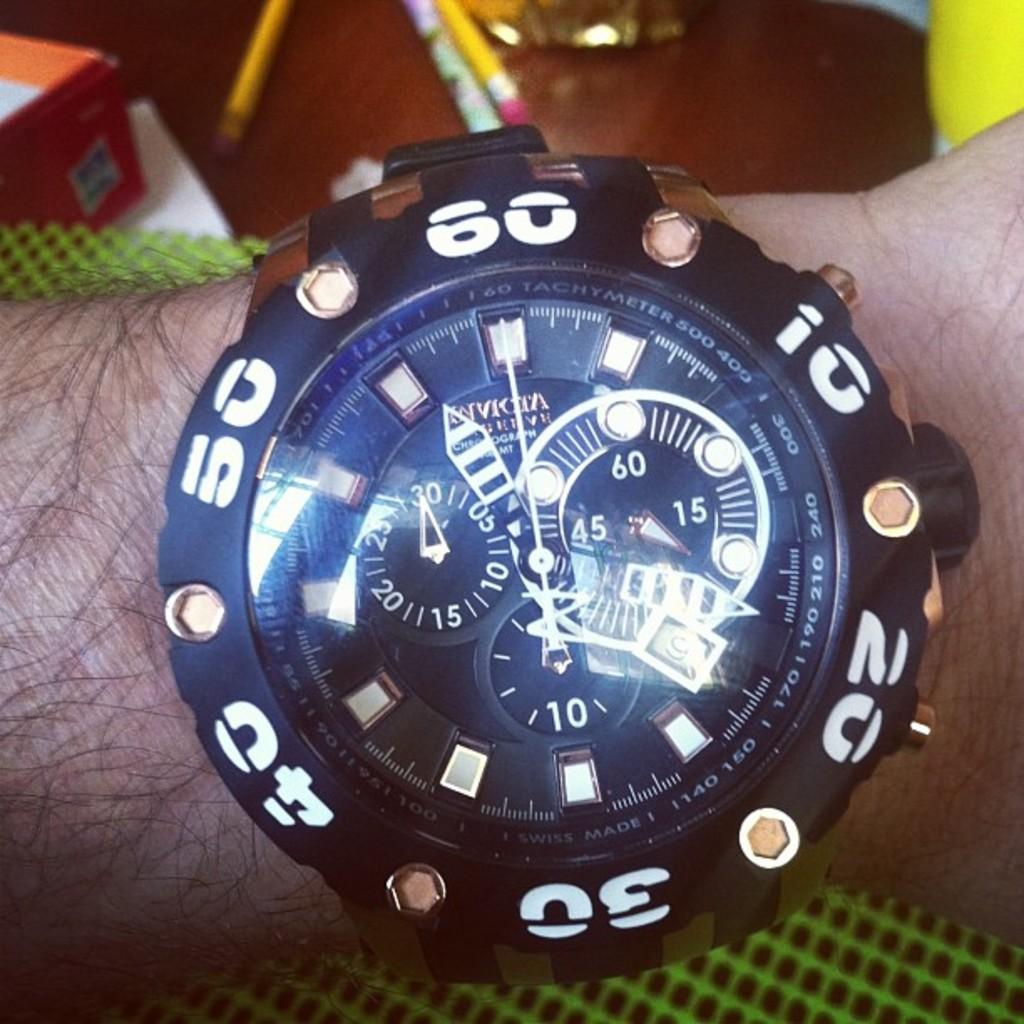<image>
Give a short and clear explanation of the subsequent image. Person wearing a watch with the numbe 30 on the bottom. 